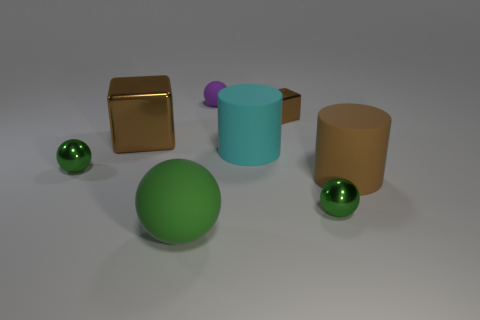Does the lighting tell us anything about the environment? The lighting is soft and diffused, creating gentle shadows under each object. There's no clear indication of a single strong light source, suggesting an environment with overall ambient lighting, perhaps from multiple sources or a large indirect light. This type of lighting is common in studio renderings or controlled indoor settings where harsh shadows are minimized. 